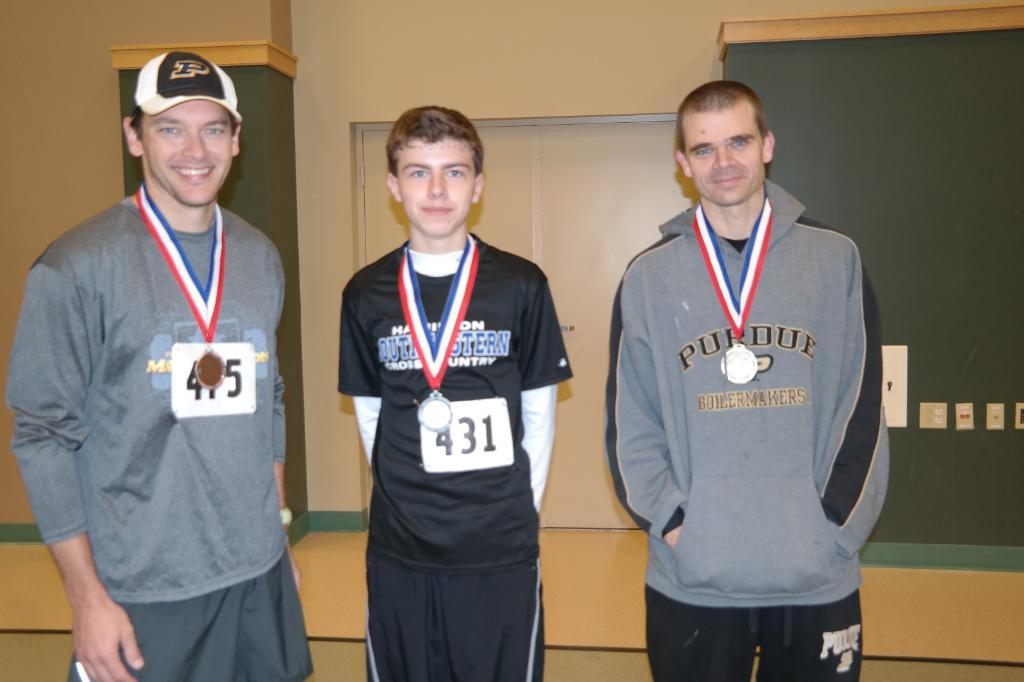<image>
Offer a succinct explanation of the picture presented. Three people receive medals at a convention, including number 431. 